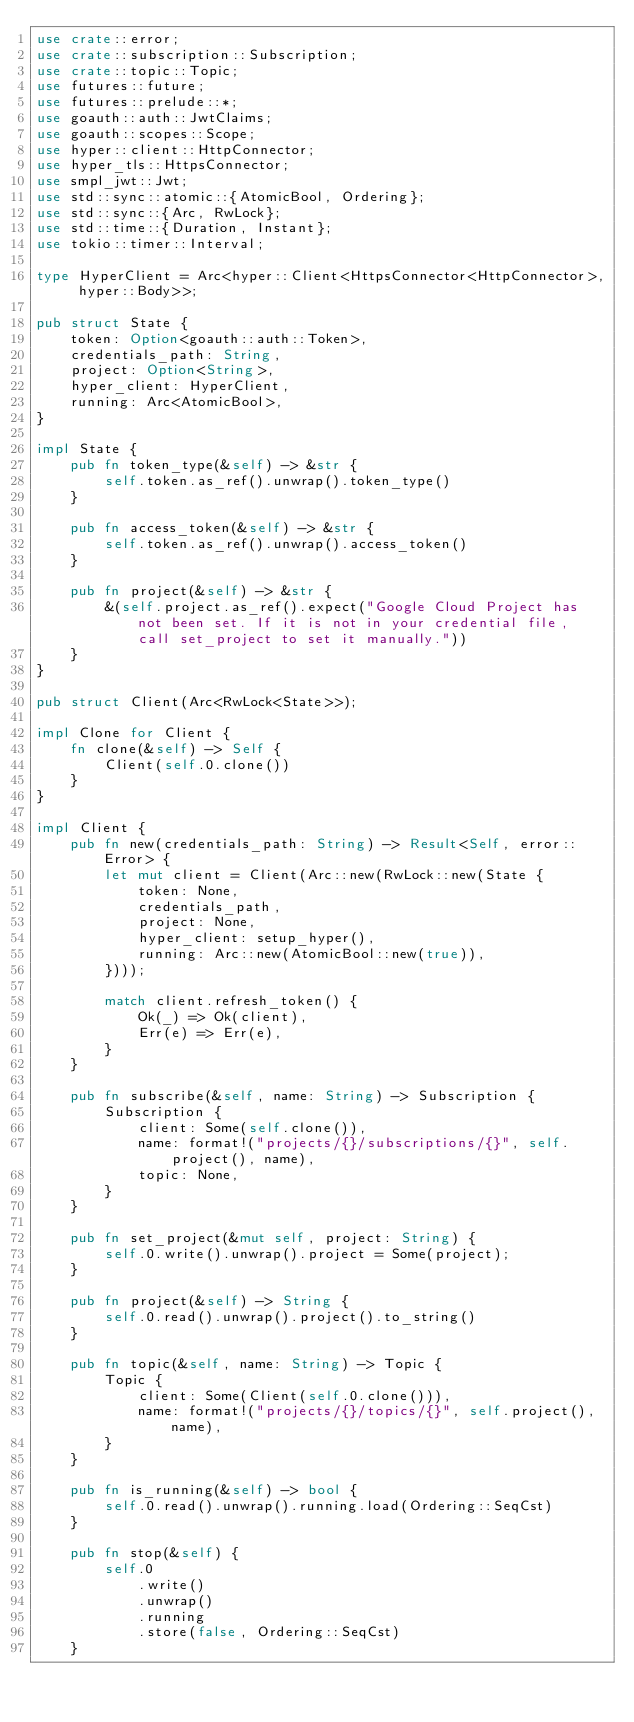<code> <loc_0><loc_0><loc_500><loc_500><_Rust_>use crate::error;
use crate::subscription::Subscription;
use crate::topic::Topic;
use futures::future;
use futures::prelude::*;
use goauth::auth::JwtClaims;
use goauth::scopes::Scope;
use hyper::client::HttpConnector;
use hyper_tls::HttpsConnector;
use smpl_jwt::Jwt;
use std::sync::atomic::{AtomicBool, Ordering};
use std::sync::{Arc, RwLock};
use std::time::{Duration, Instant};
use tokio::timer::Interval;

type HyperClient = Arc<hyper::Client<HttpsConnector<HttpConnector>, hyper::Body>>;

pub struct State {
    token: Option<goauth::auth::Token>,
    credentials_path: String,
    project: Option<String>,
    hyper_client: HyperClient,
    running: Arc<AtomicBool>,
}

impl State {
    pub fn token_type(&self) -> &str {
        self.token.as_ref().unwrap().token_type()
    }

    pub fn access_token(&self) -> &str {
        self.token.as_ref().unwrap().access_token()
    }

    pub fn project(&self) -> &str {
        &(self.project.as_ref().expect("Google Cloud Project has not been set. If it is not in your credential file, call set_project to set it manually."))
    }
}

pub struct Client(Arc<RwLock<State>>);

impl Clone for Client {
    fn clone(&self) -> Self {
        Client(self.0.clone())
    }
}

impl Client {
    pub fn new(credentials_path: String) -> Result<Self, error::Error> {
        let mut client = Client(Arc::new(RwLock::new(State {
            token: None,
            credentials_path,
            project: None,
            hyper_client: setup_hyper(),
            running: Arc::new(AtomicBool::new(true)),
        })));

        match client.refresh_token() {
            Ok(_) => Ok(client),
            Err(e) => Err(e),
        }
    }

    pub fn subscribe(&self, name: String) -> Subscription {
        Subscription {
            client: Some(self.clone()),
            name: format!("projects/{}/subscriptions/{}", self.project(), name),
            topic: None,
        }
    }

    pub fn set_project(&mut self, project: String) {
        self.0.write().unwrap().project = Some(project);
    }

    pub fn project(&self) -> String {
        self.0.read().unwrap().project().to_string()
    }

    pub fn topic(&self, name: String) -> Topic {
        Topic {
            client: Some(Client(self.0.clone())),
            name: format!("projects/{}/topics/{}", self.project(), name),
        }
    }

    pub fn is_running(&self) -> bool {
        self.0.read().unwrap().running.load(Ordering::SeqCst)
    }

    pub fn stop(&self) {
        self.0
            .write()
            .unwrap()
            .running
            .store(false, Ordering::SeqCst)
    }
</code> 